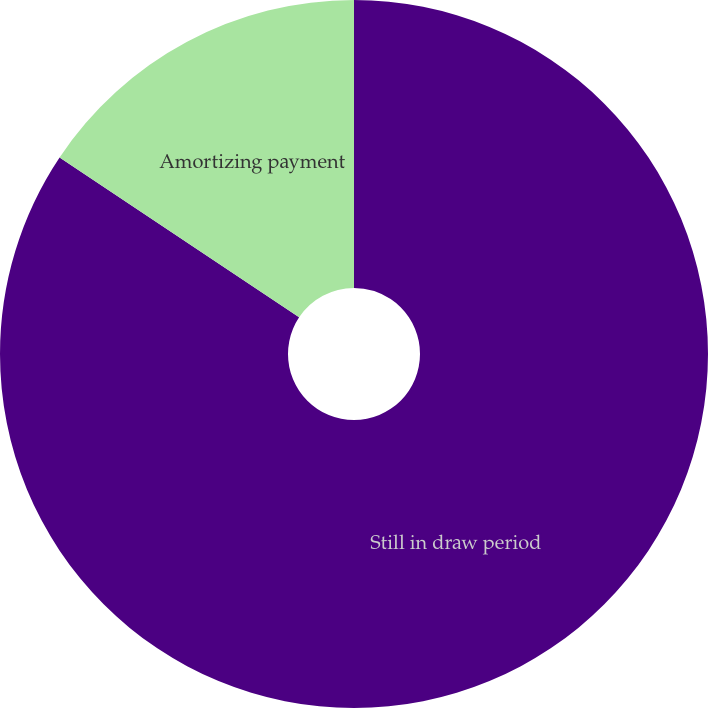Convert chart. <chart><loc_0><loc_0><loc_500><loc_500><pie_chart><fcel>Still in draw period<fcel>Amortizing payment<nl><fcel>84.37%<fcel>15.63%<nl></chart> 